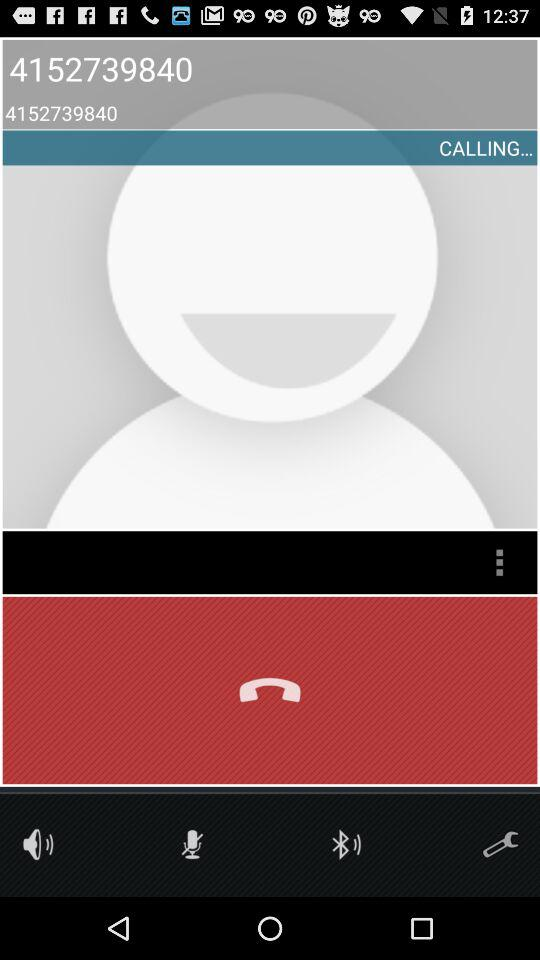What is the number of the person whom you are calling? The number of the person is 4152739840. 